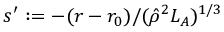Convert formula to latex. <formula><loc_0><loc_0><loc_500><loc_500>s ^ { \prime } \colon = - ( r - r _ { 0 } ) / ( \hat { \rho } ^ { 2 } L _ { A } ) ^ { 1 / 3 }</formula> 